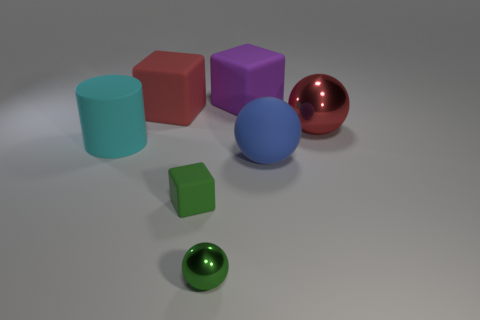Add 2 tiny cubes. How many objects exist? 9 Subtract all cylinders. How many objects are left? 6 Subtract all purple blocks. Subtract all large purple cubes. How many objects are left? 5 Add 7 blue matte balls. How many blue matte balls are left? 8 Add 5 big red shiny cylinders. How many big red shiny cylinders exist? 5 Subtract 0 purple spheres. How many objects are left? 7 